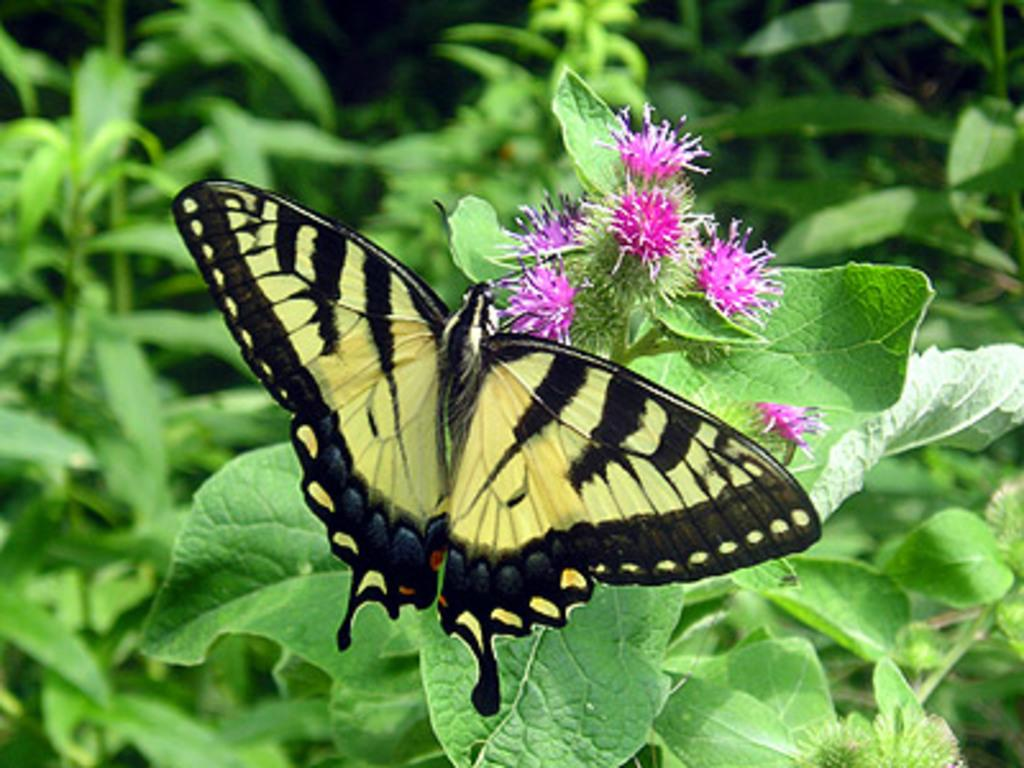What types of living organisms can be seen in the image? Plants and flowers are visible in the image. Is there any other type of living organism in the image? Yes, there is a butterfly in the image. What type of tank can be seen in the image? There is no tank present in the image. What curve is visible in the image? There is no curve mentioned or visible in the image. 